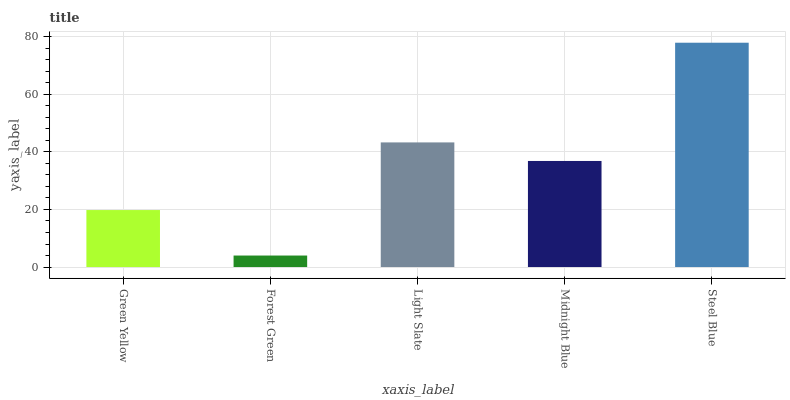Is Forest Green the minimum?
Answer yes or no. Yes. Is Steel Blue the maximum?
Answer yes or no. Yes. Is Light Slate the minimum?
Answer yes or no. No. Is Light Slate the maximum?
Answer yes or no. No. Is Light Slate greater than Forest Green?
Answer yes or no. Yes. Is Forest Green less than Light Slate?
Answer yes or no. Yes. Is Forest Green greater than Light Slate?
Answer yes or no. No. Is Light Slate less than Forest Green?
Answer yes or no. No. Is Midnight Blue the high median?
Answer yes or no. Yes. Is Midnight Blue the low median?
Answer yes or no. Yes. Is Steel Blue the high median?
Answer yes or no. No. Is Steel Blue the low median?
Answer yes or no. No. 